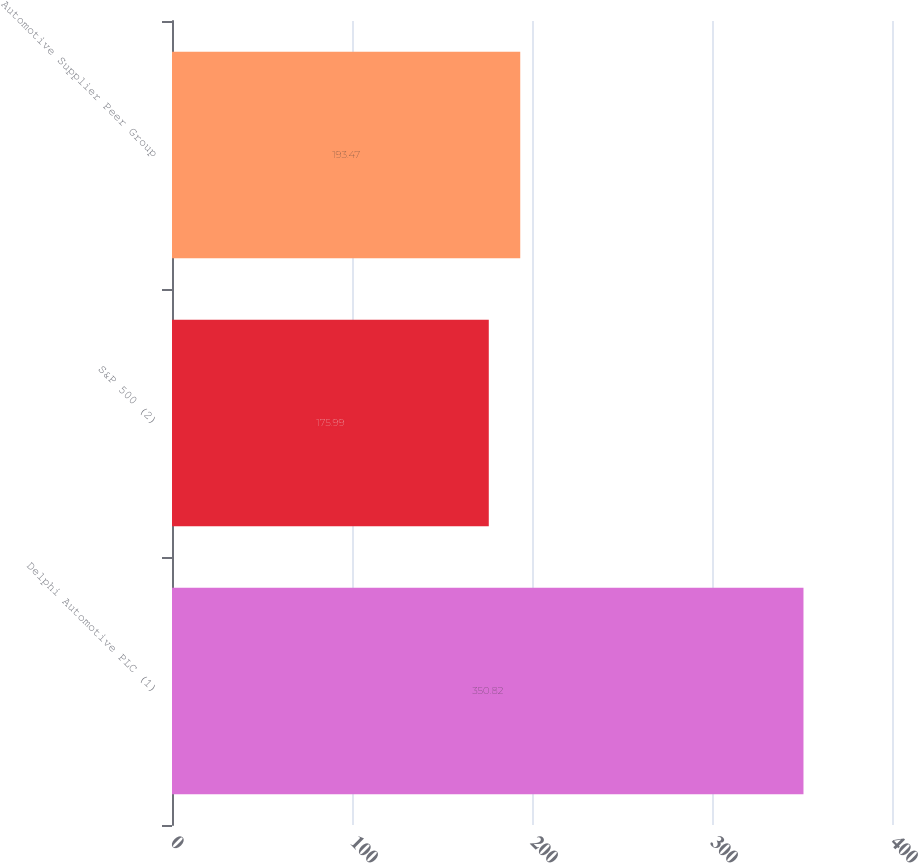Convert chart. <chart><loc_0><loc_0><loc_500><loc_500><bar_chart><fcel>Delphi Automotive PLC (1)<fcel>S&P 500 (2)<fcel>Automotive Supplier Peer Group<nl><fcel>350.82<fcel>175.99<fcel>193.47<nl></chart> 